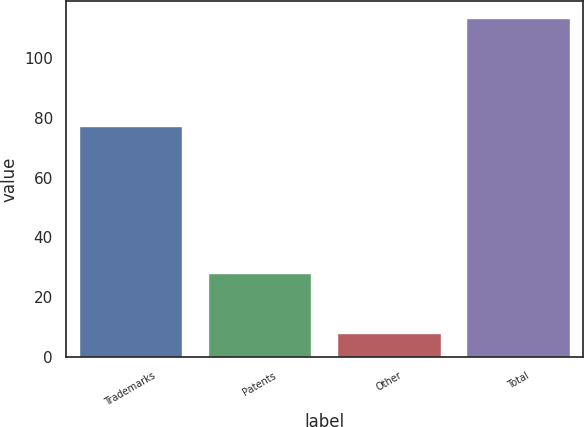<chart> <loc_0><loc_0><loc_500><loc_500><bar_chart><fcel>Trademarks<fcel>Patents<fcel>Other<fcel>Total<nl><fcel>77.1<fcel>28<fcel>8.2<fcel>113.3<nl></chart> 